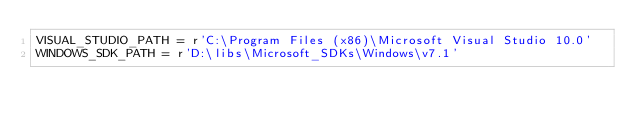Convert code to text. <code><loc_0><loc_0><loc_500><loc_500><_Python_>VISUAL_STUDIO_PATH = r'C:\Program Files (x86)\Microsoft Visual Studio 10.0'
WINDOWS_SDK_PATH = r'D:\libs\Microsoft_SDKs\Windows\v7.1'</code> 